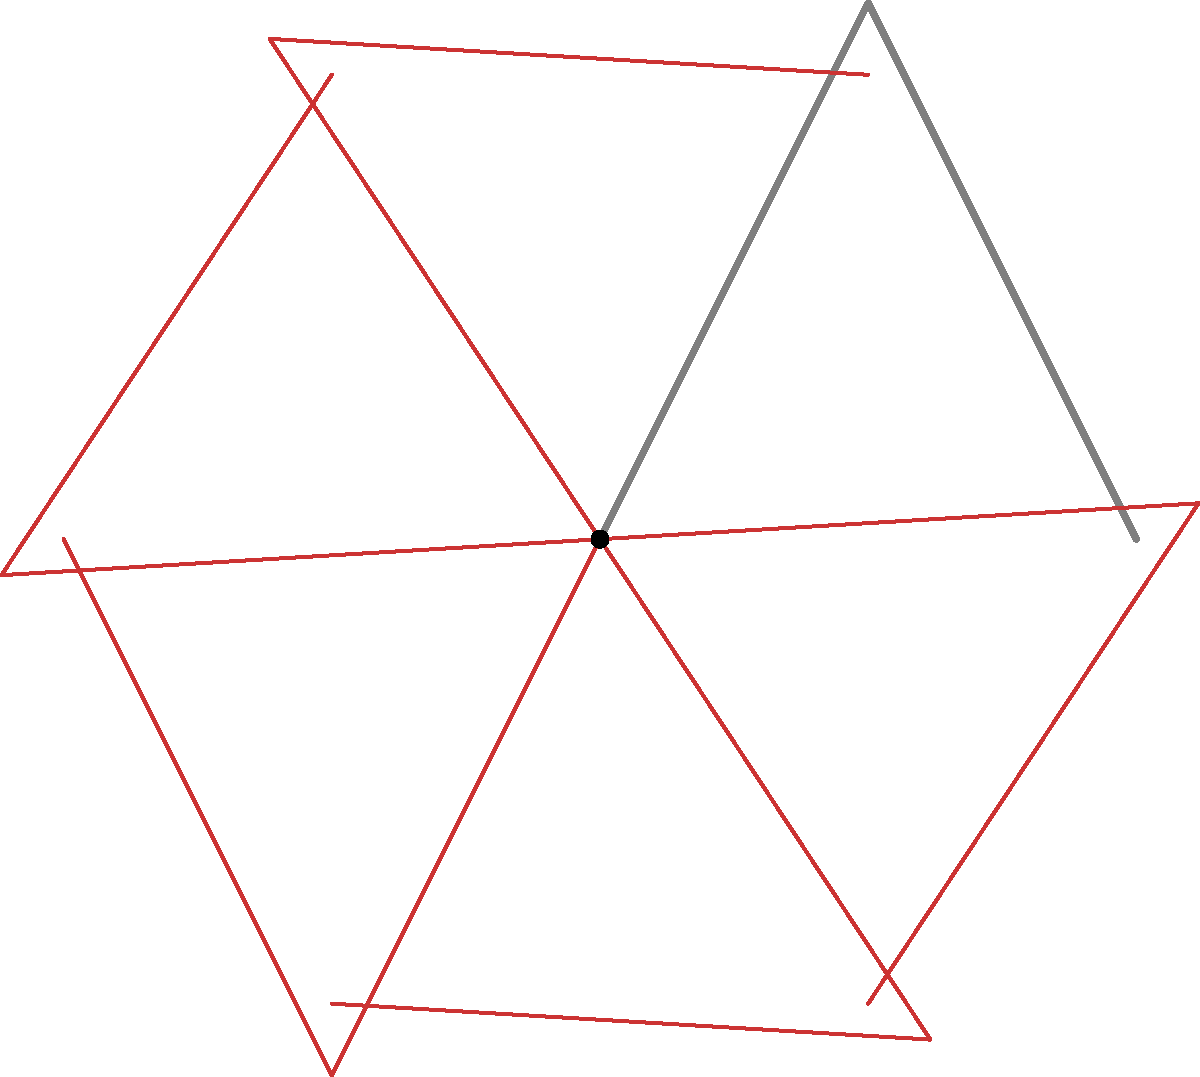The iconic shape of the Mackinac Bridge is represented by a simplified outline. If this outline is rotated around its base point to create a circular pattern, how many rotations (including the original position) are needed to complete a full 360° circle? To solve this problem, we need to follow these steps:

1. Observe the given diagram. The original bridge outline is shown in gray, and the rotated copies are in red.

2. Count the number of bridge outlines visible in the diagram:
   - 1 original gray outline
   - 5 rotated red outlines

3. The total number of outlines visible is 6.

4. To determine if this completes a full 360° circle, we need to calculate the angle between each rotation:
   $\frac{360°}{6} = 60°$

5. Since 60° is a factor of 360°, we can confirm that 6 rotations (including the original position) complete a full circle.

6. We can verify this mathematically:
   $6 \times 60° = 360°$

Therefore, 6 rotations (including the original position) are needed to complete a full 360° circle.
Answer: 6 rotations 